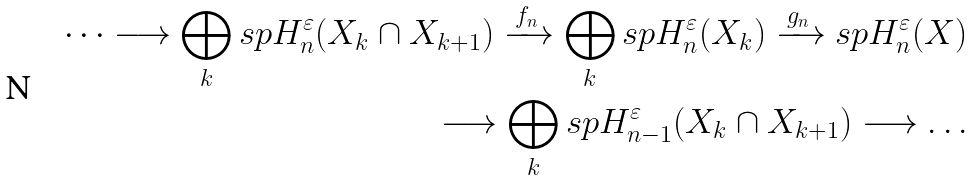<formula> <loc_0><loc_0><loc_500><loc_500>\dots \longrightarrow \bigoplus _ { k } s p H ^ { \varepsilon } _ { n } ( X _ { k } \cap X _ { k + 1 } ) \xrightarrow { \, f _ { n } \, } \bigoplus _ { k } s p H ^ { \varepsilon } _ { n } ( X _ { k } ) \xrightarrow { \, g _ { n } \, } s p H ^ { \varepsilon } _ { n } ( X ) \\ \longrightarrow \bigoplus _ { k } s p H ^ { \varepsilon } _ { n - 1 } ( X _ { k } \cap X _ { k + 1 } ) \longrightarrow \dots</formula> 